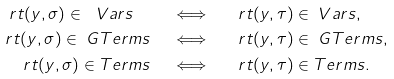<formula> <loc_0><loc_0><loc_500><loc_500>\ r t ( y , \sigma ) \in \ V a r s \quad & \iff \quad \ r t ( y , \tau ) \in \ V a r s , \\ \ r t ( y , \sigma ) \in \ G T e r m s \quad & \iff \quad \ r t ( y , \tau ) \in \ G T e r m s , \\ \ r t ( y , \sigma ) \in \L T e r m s \quad & \iff \quad \ r t ( y , \tau ) \in \L T e r m s .</formula> 